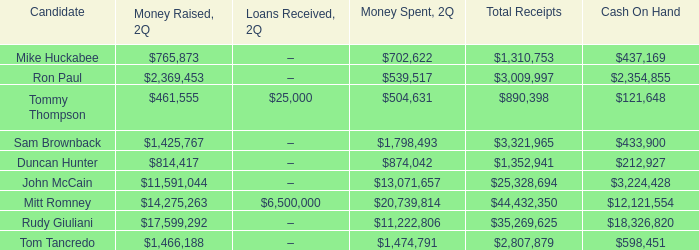Name the loans received for 2Q having total receipts of $25,328,694 –. 